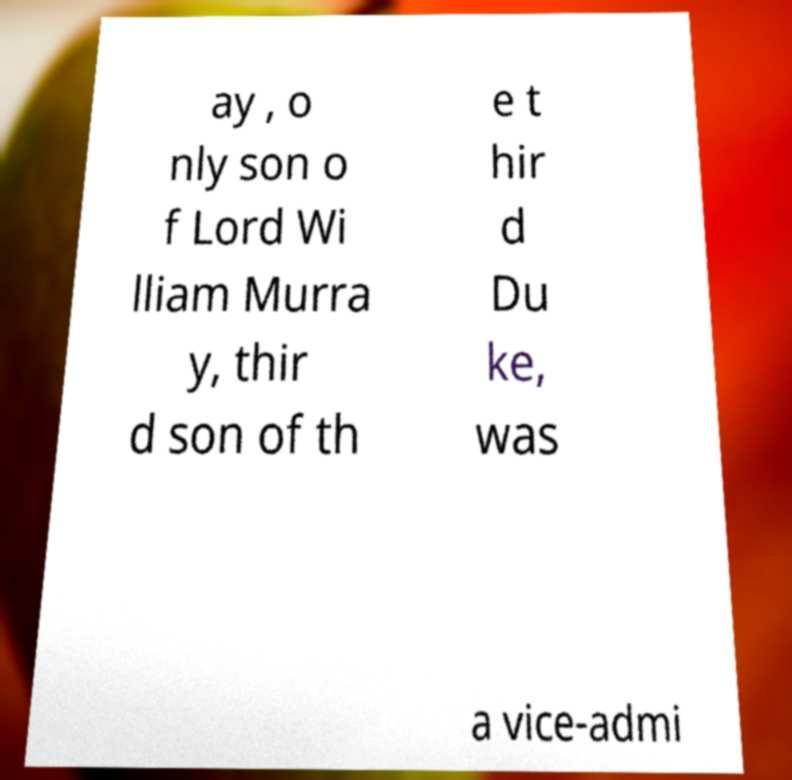There's text embedded in this image that I need extracted. Can you transcribe it verbatim? ay , o nly son o f Lord Wi lliam Murra y, thir d son of th e t hir d Du ke, was a vice-admi 